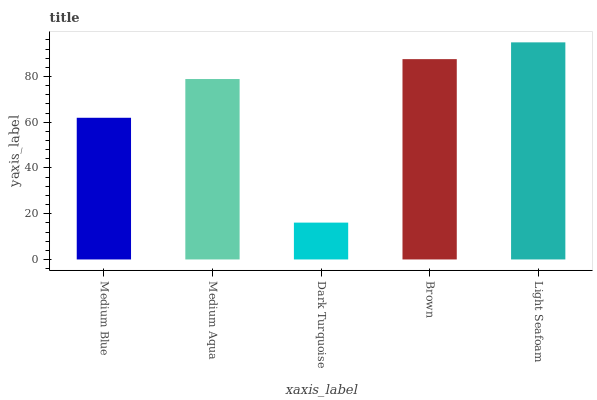Is Dark Turquoise the minimum?
Answer yes or no. Yes. Is Light Seafoam the maximum?
Answer yes or no. Yes. Is Medium Aqua the minimum?
Answer yes or no. No. Is Medium Aqua the maximum?
Answer yes or no. No. Is Medium Aqua greater than Medium Blue?
Answer yes or no. Yes. Is Medium Blue less than Medium Aqua?
Answer yes or no. Yes. Is Medium Blue greater than Medium Aqua?
Answer yes or no. No. Is Medium Aqua less than Medium Blue?
Answer yes or no. No. Is Medium Aqua the high median?
Answer yes or no. Yes. Is Medium Aqua the low median?
Answer yes or no. Yes. Is Medium Blue the high median?
Answer yes or no. No. Is Brown the low median?
Answer yes or no. No. 